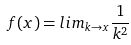<formula> <loc_0><loc_0><loc_500><loc_500>f ( x ) = l i m _ { k \rightarrow x } \frac { 1 } { k ^ { 2 } }</formula> 